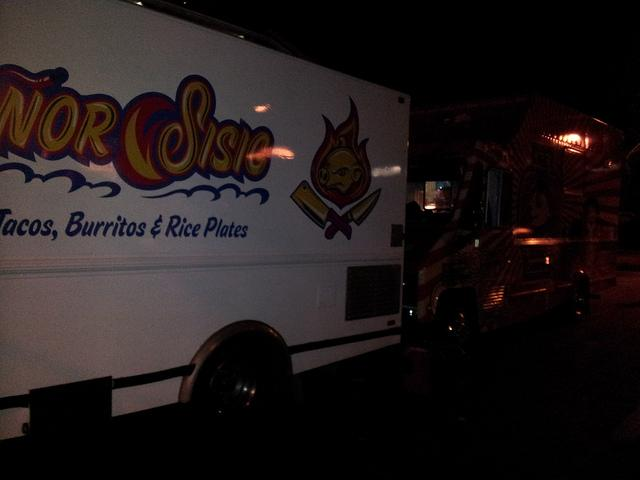What does the white truck do?

Choices:
A) sells food
B) transports passengers
C) transports utensils
D) transports rice sells food 